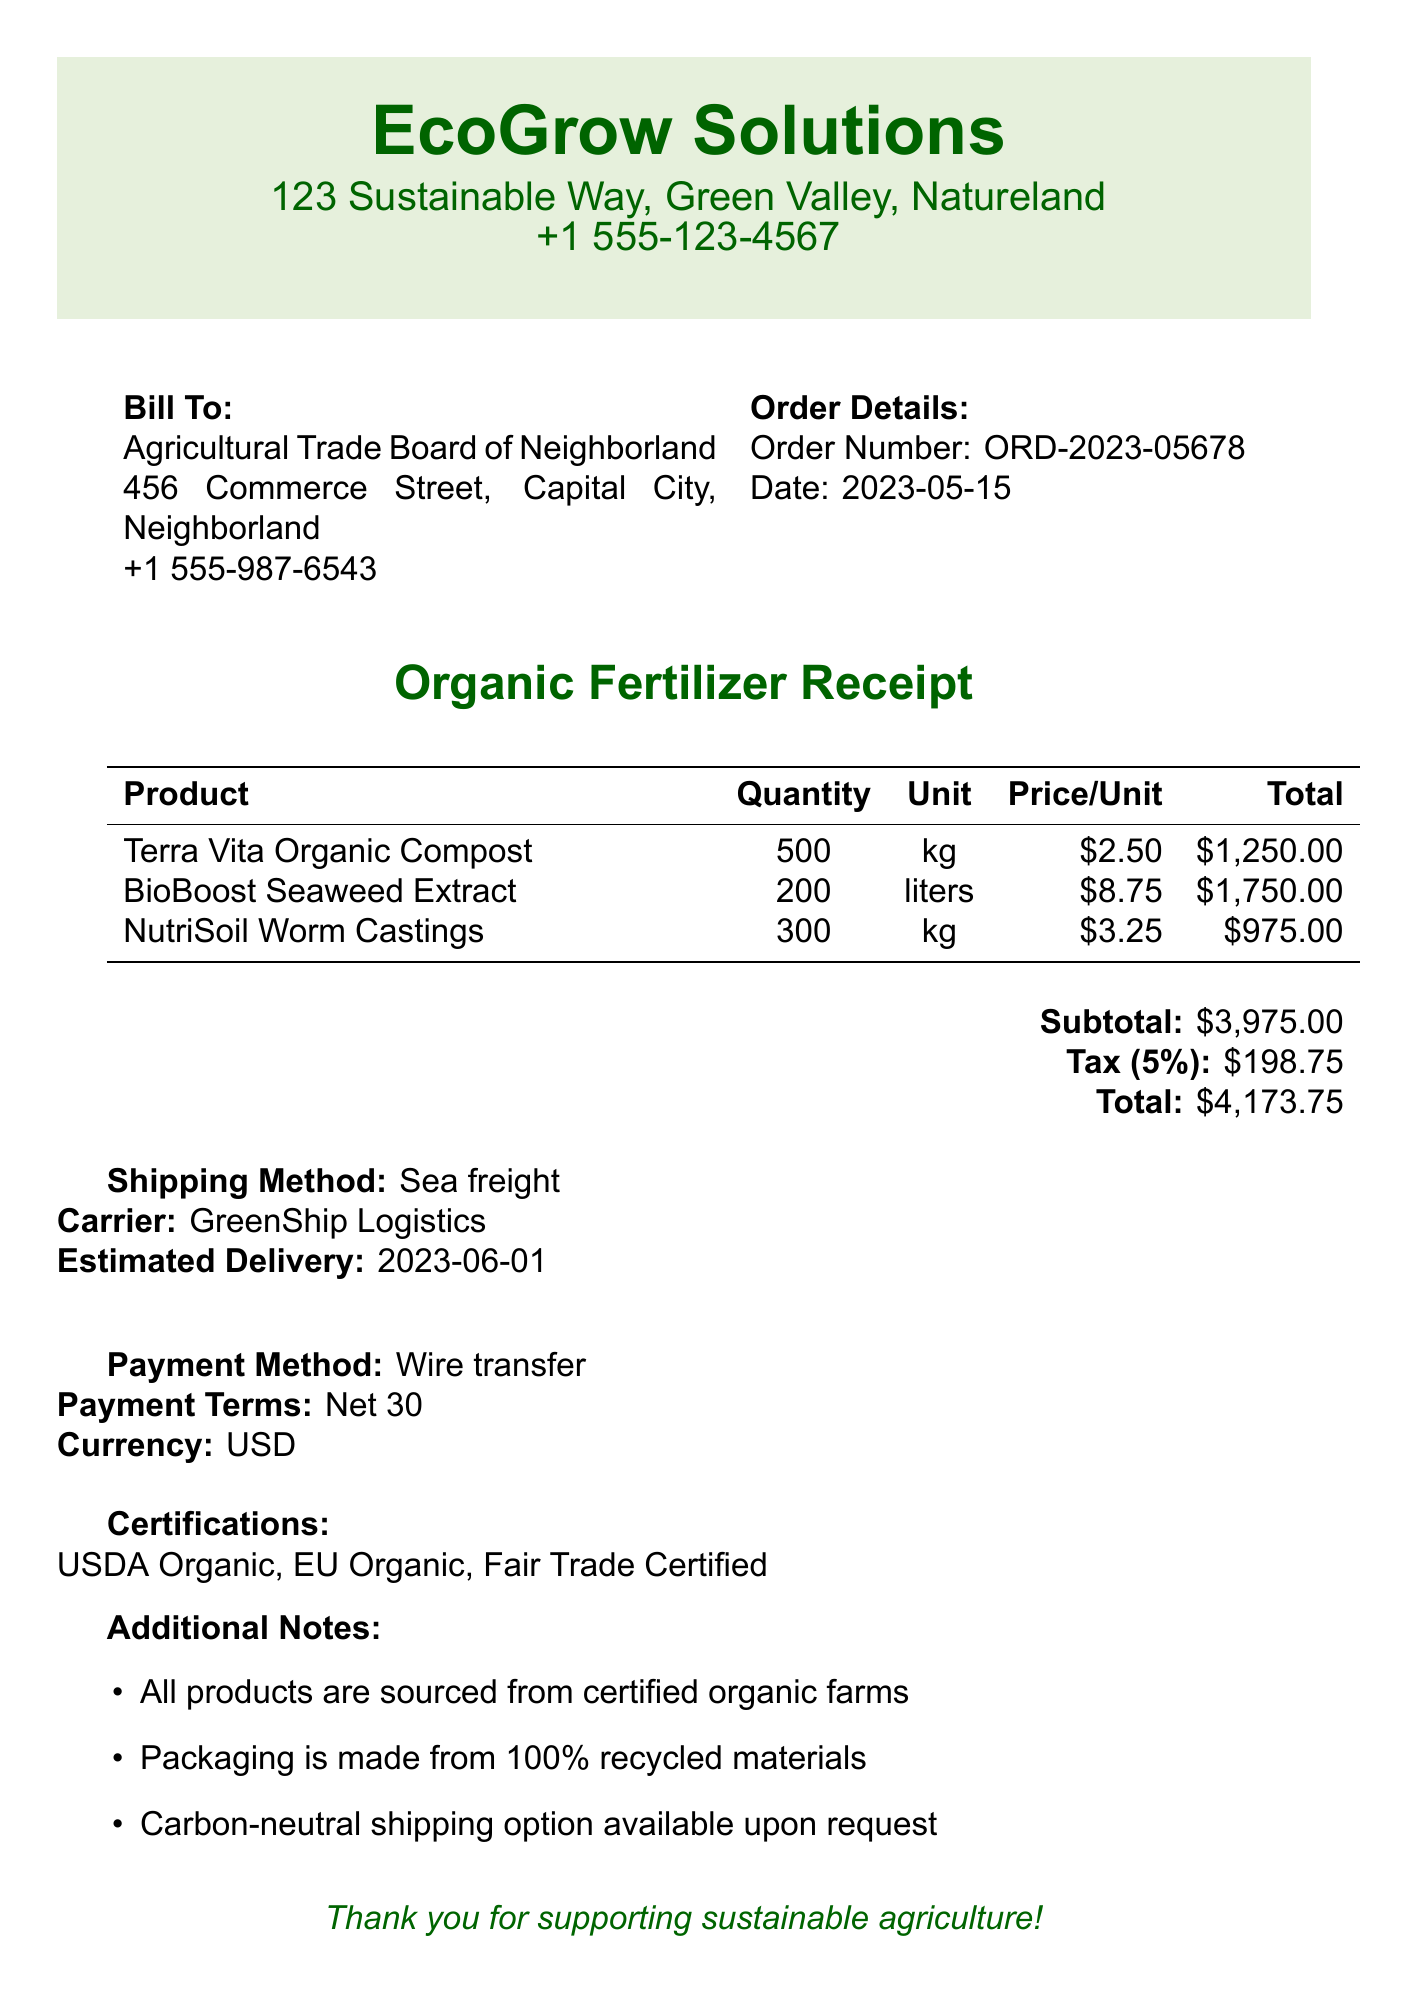What is the name of the supplier? The supplier's name is listed at the top of the document under EcoGrow Solutions.
Answer: EcoGrow Solutions What is the total amount due? The total amount due is calculated from the subtotal and tax in the payment section.
Answer: $4,173.75 How many liters of BioBoost Seaweed Extract were ordered? The quantity of BioBoost Seaweed Extract is provided in the product list of the receipt.
Answer: 200 What is the payment method? The payment method is explicitly mentioned in the payment section of the receipt.
Answer: Wire transfer What is the tax rate applied to the order? The tax rate can be found in the payment details where it states 5%.
Answer: 5% What are the certifications listed for the products? The certifications are enumerated at the bottom of the document, providing assurance of sustainability.
Answer: USDA Organic, EU Organic, Fair Trade Certified What is the estimated delivery date? The estimated delivery date is provided under the shipping section of the receipt.
Answer: 2023-06-01 How much was paid for NutriSoil Worm Castings? The total price for NutriSoil Worm Castings is mentioned in the product list on the receipt.
Answer: $975.00 